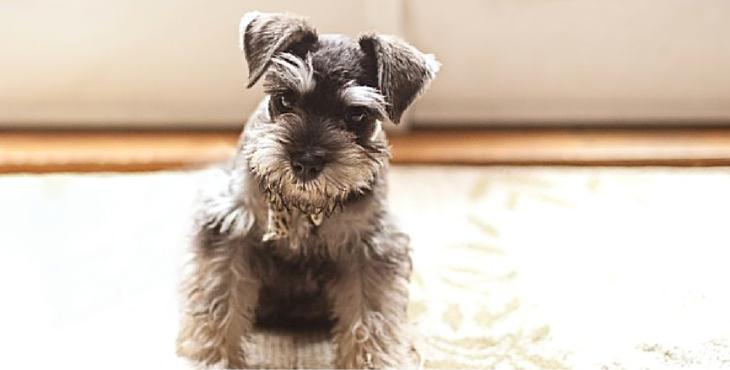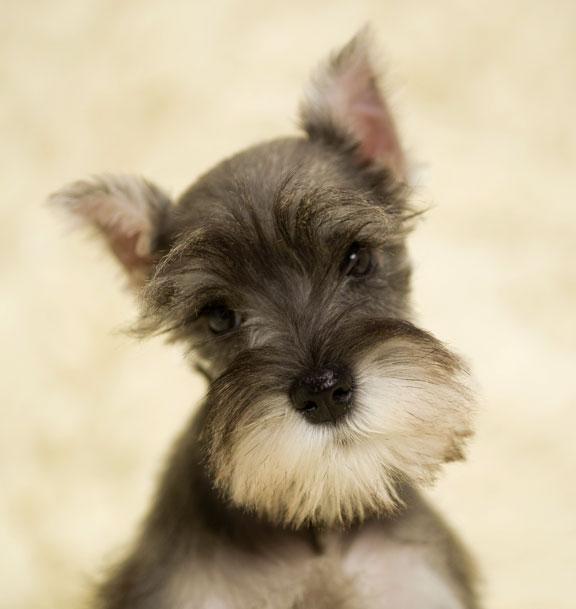The first image is the image on the left, the second image is the image on the right. Assess this claim about the two images: "A dog is sitting on wood floor.". Correct or not? Answer yes or no. No. The first image is the image on the left, the second image is the image on the right. For the images shown, is this caption "An image shows a schnauzer posed on a wood plank floor." true? Answer yes or no. No. 